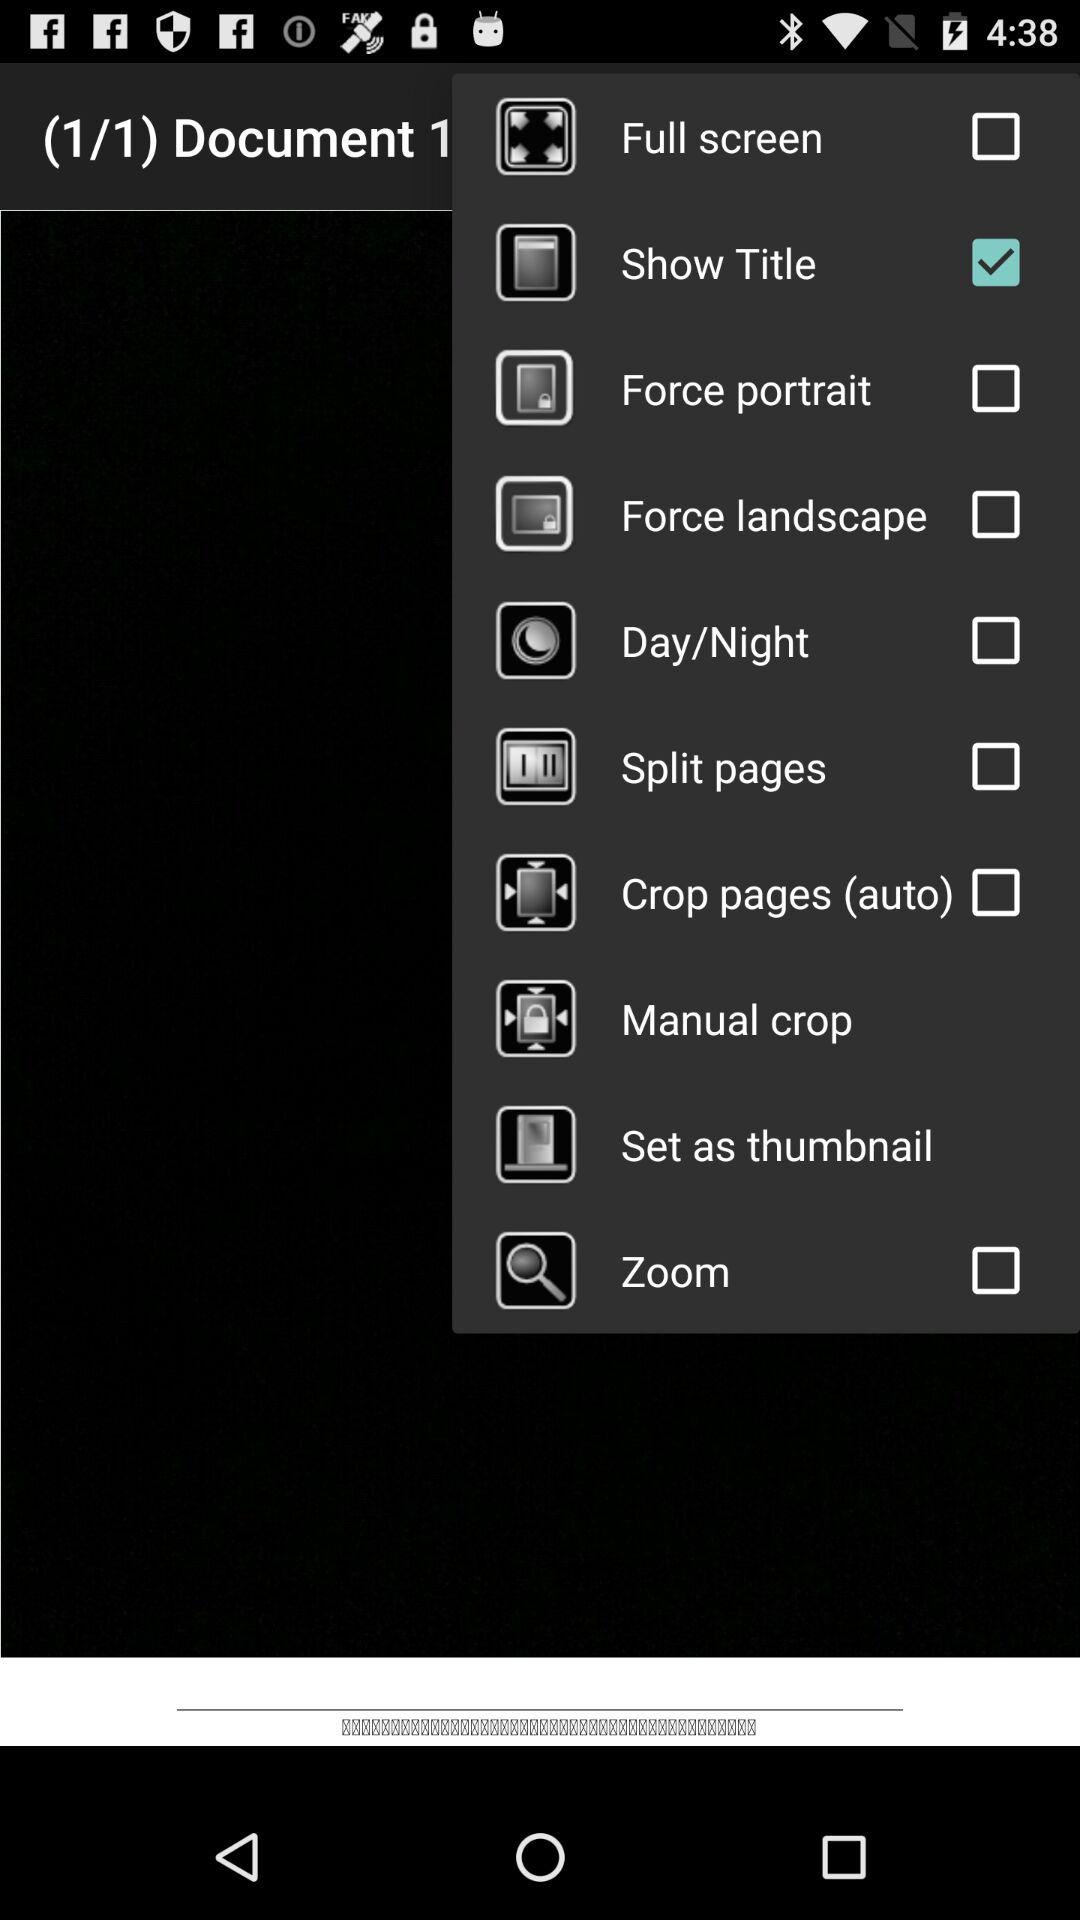How many documents are there? There is 1 document. 